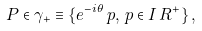<formula> <loc_0><loc_0><loc_500><loc_500>P \in \gamma _ { + } \equiv \{ e ^ { - i \theta } \, p , \, p \in I \, R ^ { + } \} \, ,</formula> 